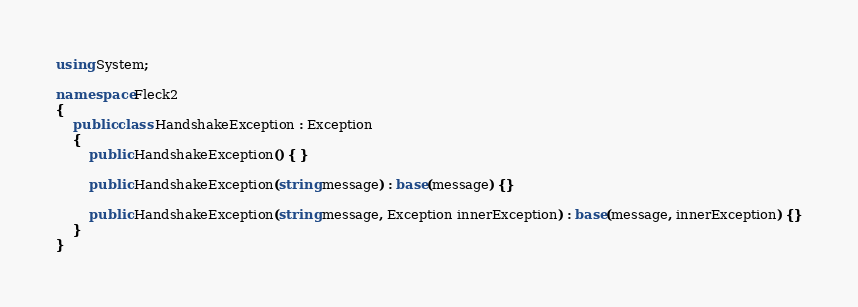Convert code to text. <code><loc_0><loc_0><loc_500><loc_500><_C#_>using System;

namespace Fleck2
{
    public class HandshakeException : Exception
    {
        public HandshakeException() { }
        
        public HandshakeException(string message) : base(message) {}
        
        public HandshakeException(string message, Exception innerException) : base(message, innerException) {}
    }
}

</code> 